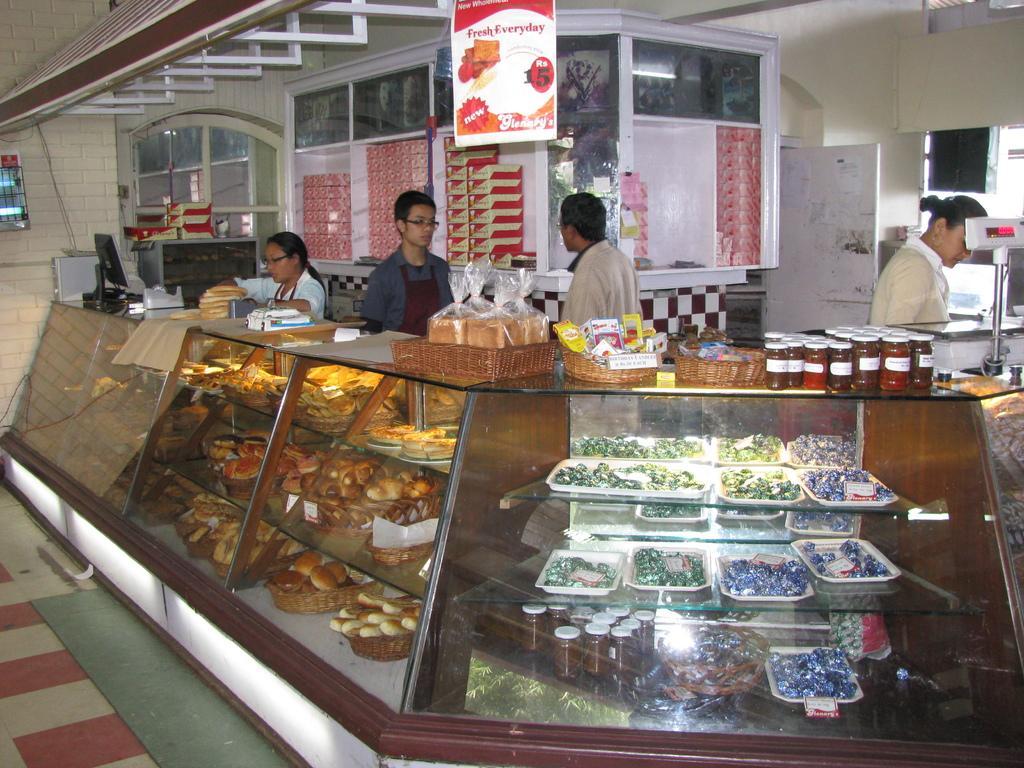Describe this image in one or two sentences. Here in this picture we can see a shop, in which we can see a counter present and on that we can see number of food items present and inside that we can see racks that are filled with bakery items and food items and we can also see people standing behind that and we can also see a weighing machine present and we can see a banner hanging and we can see a price card present over there and we can also see boxes present in the racks and on the left side we can see a system present. 